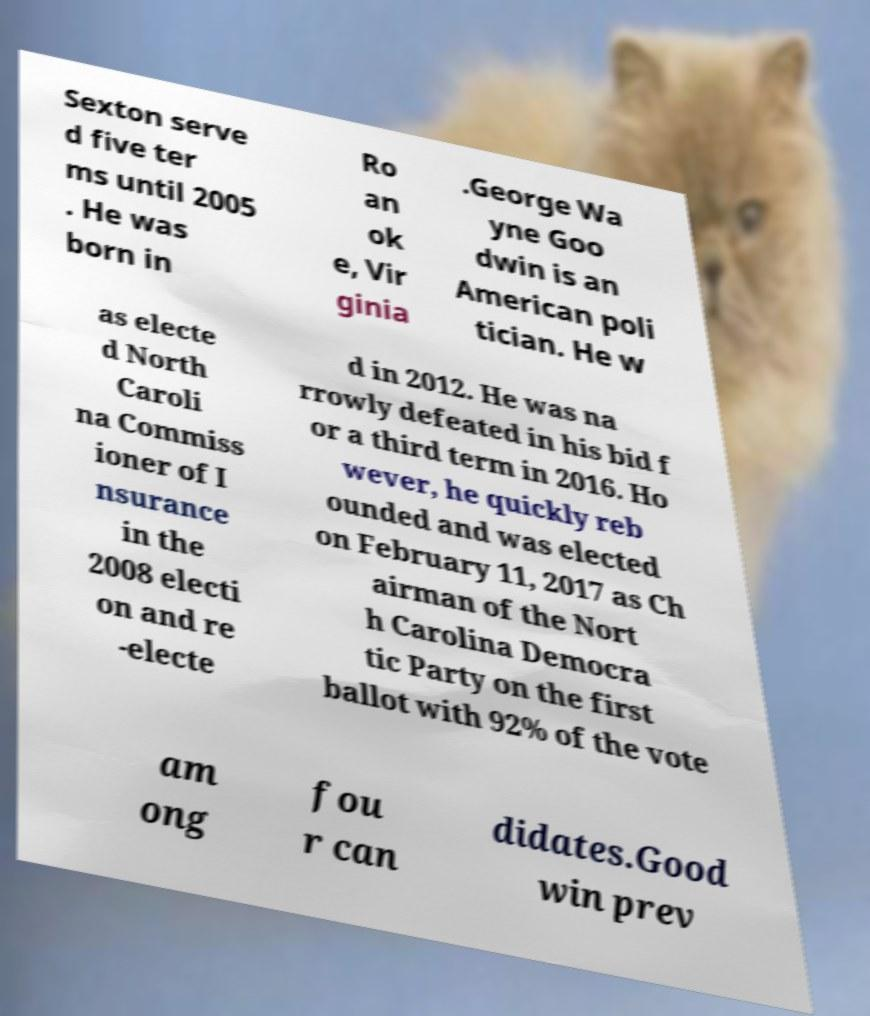Could you extract and type out the text from this image? Sexton serve d five ter ms until 2005 . He was born in Ro an ok e, Vir ginia .George Wa yne Goo dwin is an American poli tician. He w as electe d North Caroli na Commiss ioner of I nsurance in the 2008 electi on and re -electe d in 2012. He was na rrowly defeated in his bid f or a third term in 2016. Ho wever, he quickly reb ounded and was elected on February 11, 2017 as Ch airman of the Nort h Carolina Democra tic Party on the first ballot with 92% of the vote am ong fou r can didates.Good win prev 